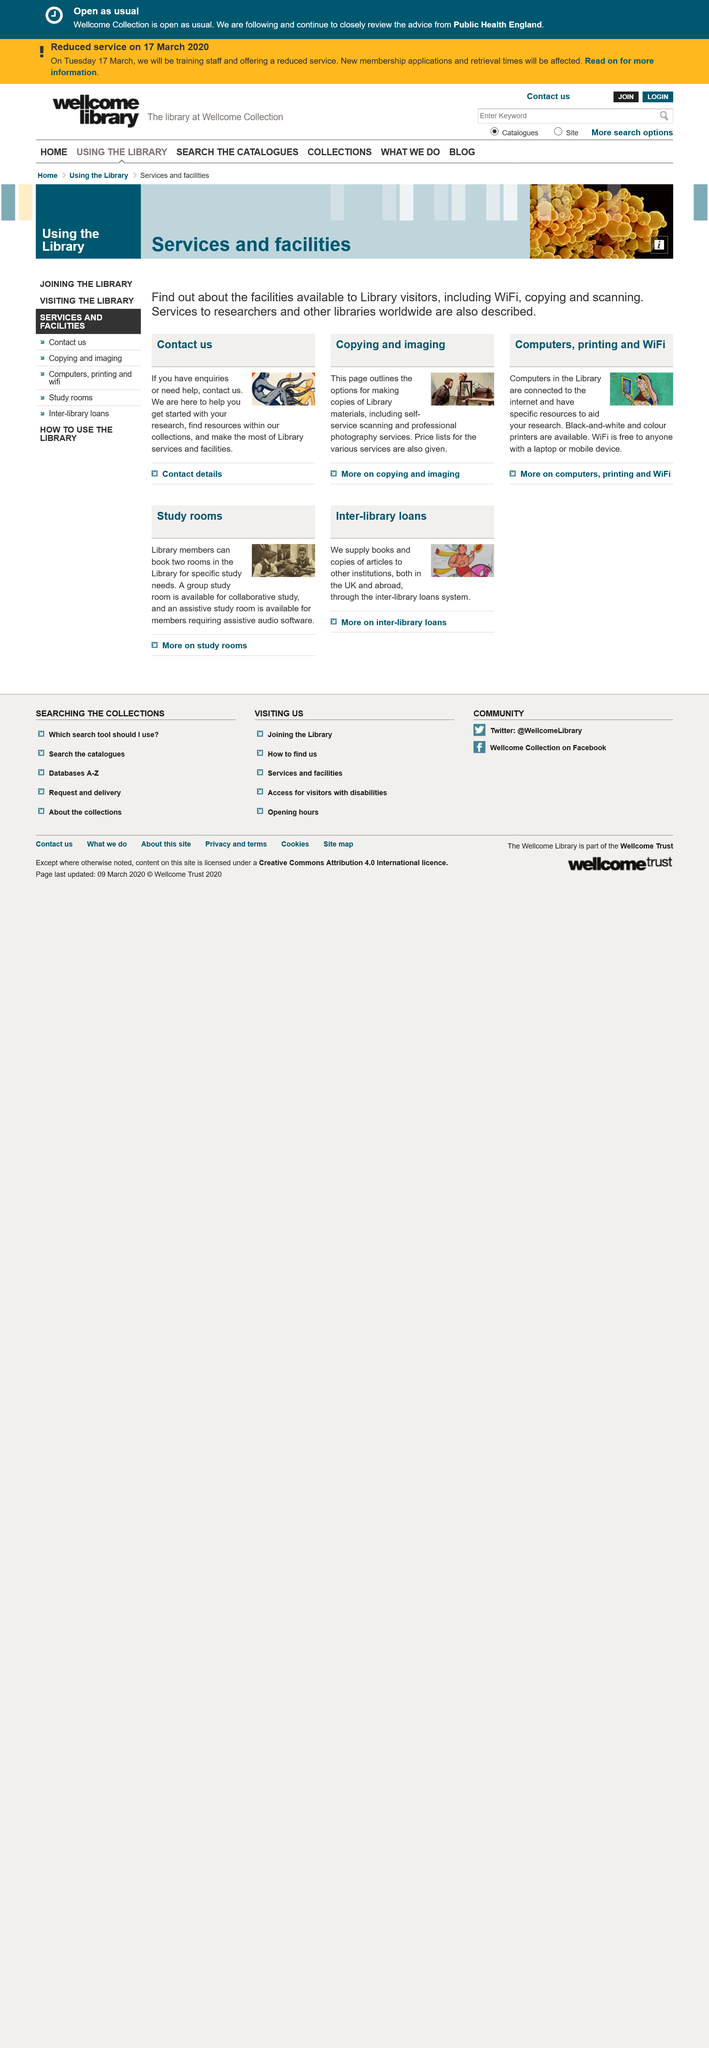Draw attention to some important aspects in this diagram. The Library provides free WiFi to anyone with a laptop or mobile device, and it is available in the Library. The Copying and Imaging page provides information on self-scanning services, which allow users to make copies of Library materials. The availability of black and white and color printers can be found in the Library. 